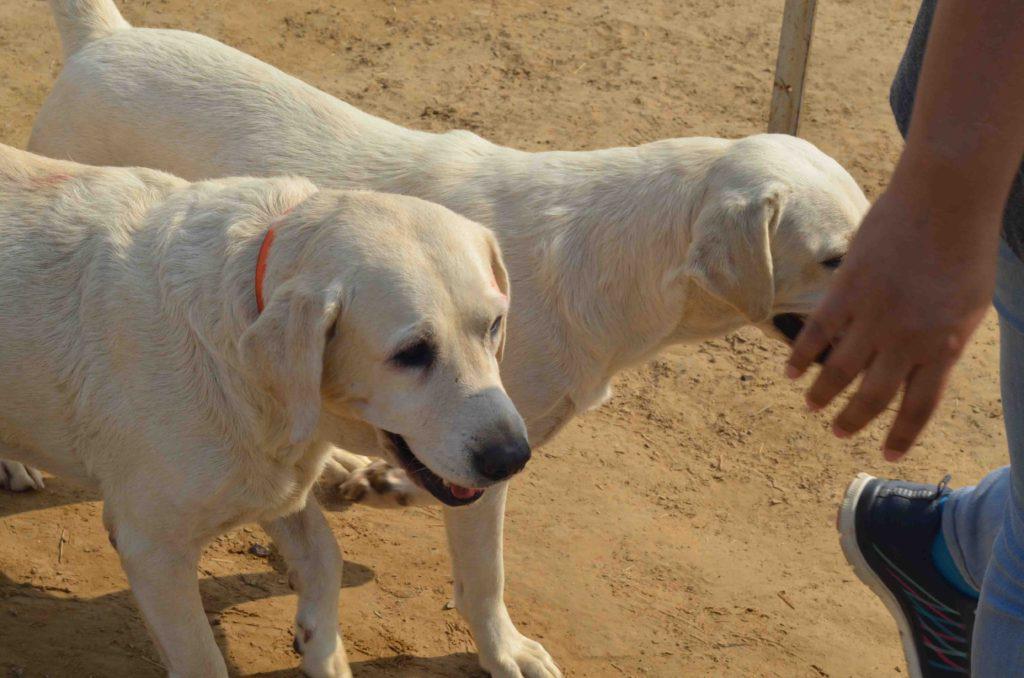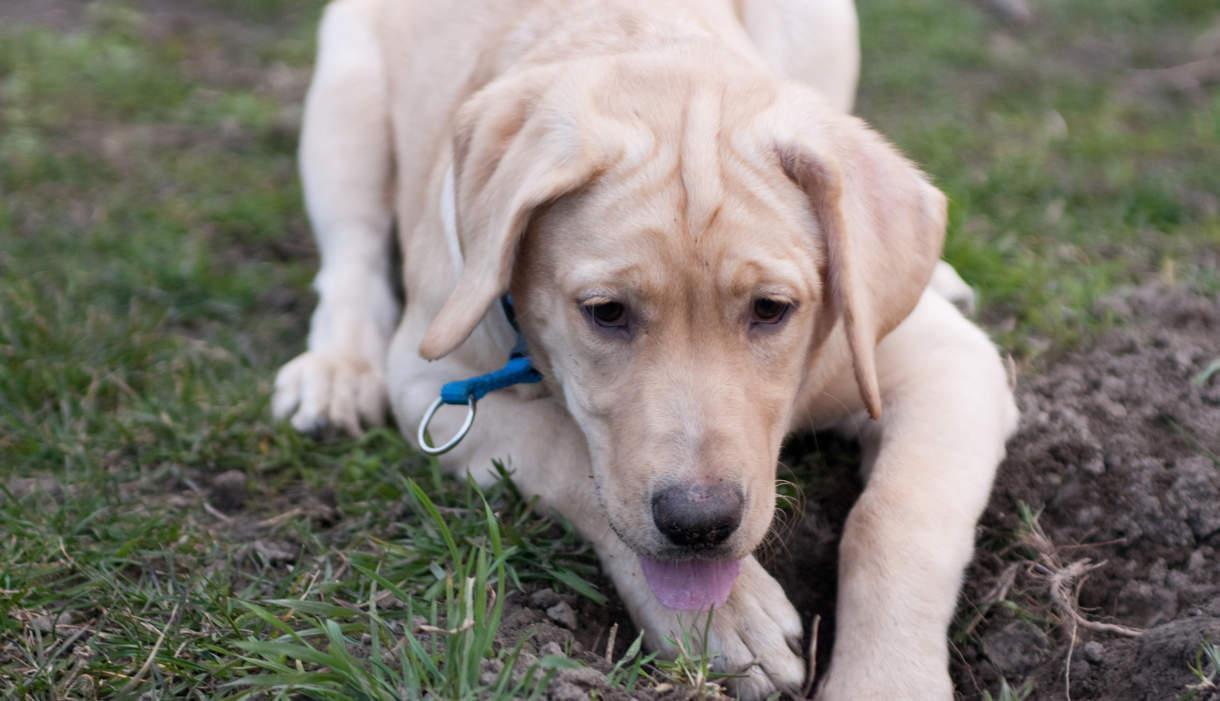The first image is the image on the left, the second image is the image on the right. Analyze the images presented: Is the assertion "An image shows one reclining dog, which is wearing a collar." valid? Answer yes or no. Yes. The first image is the image on the left, the second image is the image on the right. Considering the images on both sides, is "The right image contains one or more black labs." valid? Answer yes or no. No. 